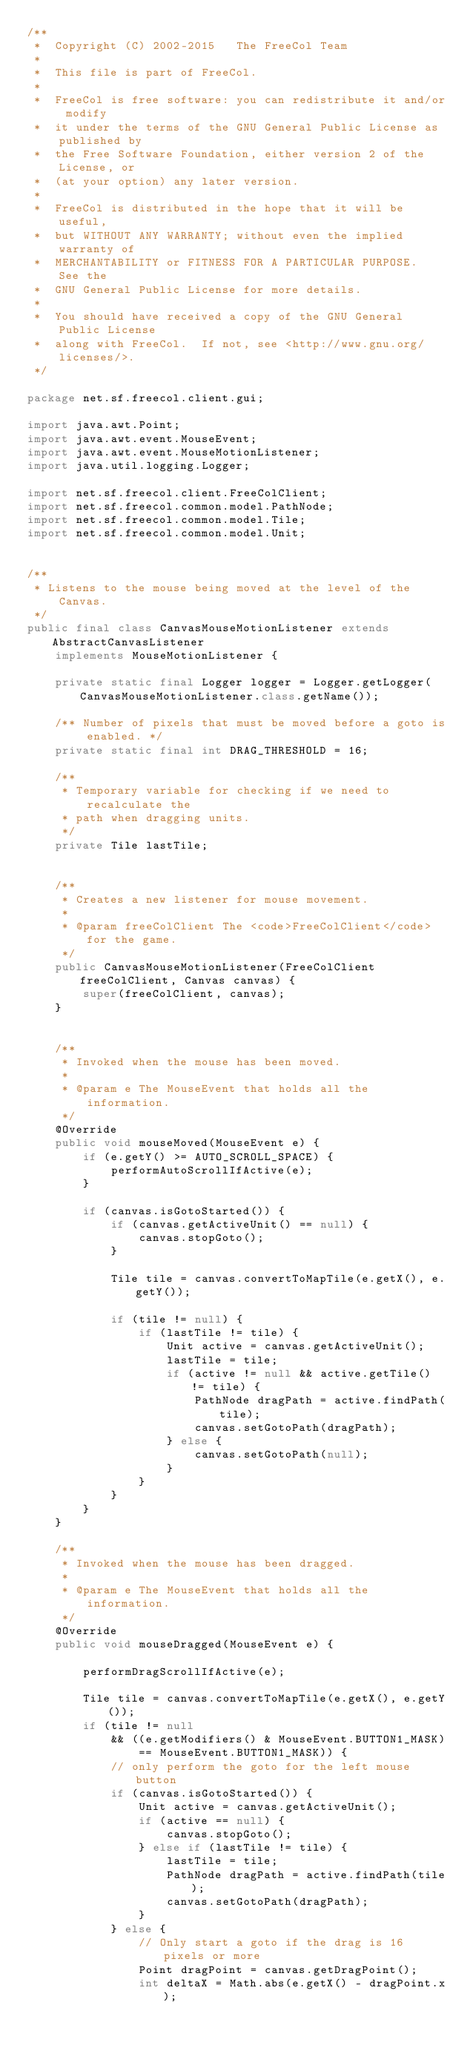<code> <loc_0><loc_0><loc_500><loc_500><_Java_>/**
 *  Copyright (C) 2002-2015   The FreeCol Team
 *
 *  This file is part of FreeCol.
 *
 *  FreeCol is free software: you can redistribute it and/or modify
 *  it under the terms of the GNU General Public License as published by
 *  the Free Software Foundation, either version 2 of the License, or
 *  (at your option) any later version.
 *
 *  FreeCol is distributed in the hope that it will be useful,
 *  but WITHOUT ANY WARRANTY; without even the implied warranty of
 *  MERCHANTABILITY or FITNESS FOR A PARTICULAR PURPOSE.  See the
 *  GNU General Public License for more details.
 *
 *  You should have received a copy of the GNU General Public License
 *  along with FreeCol.  If not, see <http://www.gnu.org/licenses/>.
 */

package net.sf.freecol.client.gui;

import java.awt.Point;
import java.awt.event.MouseEvent;
import java.awt.event.MouseMotionListener;
import java.util.logging.Logger;

import net.sf.freecol.client.FreeColClient;
import net.sf.freecol.common.model.PathNode;
import net.sf.freecol.common.model.Tile;
import net.sf.freecol.common.model.Unit;


/**
 * Listens to the mouse being moved at the level of the Canvas.
 */
public final class CanvasMouseMotionListener extends AbstractCanvasListener
    implements MouseMotionListener {

    private static final Logger logger = Logger.getLogger(CanvasMouseMotionListener.class.getName());

    /** Number of pixels that must be moved before a goto is enabled. */
    private static final int DRAG_THRESHOLD = 16;

    /**
     * Temporary variable for checking if we need to recalculate the
     * path when dragging units.
     */
    private Tile lastTile;
    

    /**
     * Creates a new listener for mouse movement.
     *
     * @param freeColClient The <code>FreeColClient</code> for the game.
     */
    public CanvasMouseMotionListener(FreeColClient freeColClient, Canvas canvas) {
        super(freeColClient, canvas);
    }


    /**
     * Invoked when the mouse has been moved.
     *
     * @param e The MouseEvent that holds all the information.
     */
    @Override
    public void mouseMoved(MouseEvent e) {
        if (e.getY() >= AUTO_SCROLL_SPACE) {
            performAutoScrollIfActive(e);
        }

        if (canvas.isGotoStarted()) {
            if (canvas.getActiveUnit() == null) {
                canvas.stopGoto();
            }

            Tile tile = canvas.convertToMapTile(e.getX(), e.getY());

            if (tile != null) {
                if (lastTile != tile) {
                    Unit active = canvas.getActiveUnit();
                    lastTile = tile;
                    if (active != null && active.getTile() != tile) {
                        PathNode dragPath = active.findPath(tile);
                        canvas.setGotoPath(dragPath);
                    } else {
                        canvas.setGotoPath(null);
                    }
                }
            }
        }
    }

    /**
     * Invoked when the mouse has been dragged.
     *
     * @param e The MouseEvent that holds all the information.
     */
    @Override
    public void mouseDragged(MouseEvent e) {

        performDragScrollIfActive(e);

        Tile tile = canvas.convertToMapTile(e.getX(), e.getY());
        if (tile != null
            && ((e.getModifiers() & MouseEvent.BUTTON1_MASK)
                == MouseEvent.BUTTON1_MASK)) {
            // only perform the goto for the left mouse button
            if (canvas.isGotoStarted()) {
                Unit active = canvas.getActiveUnit();
                if (active == null) {
                    canvas.stopGoto();
                } else if (lastTile != tile) {
                    lastTile = tile;
                    PathNode dragPath = active.findPath(tile);
                    canvas.setGotoPath(dragPath);
                }
            } else {
                // Only start a goto if the drag is 16 pixels or more
                Point dragPoint = canvas.getDragPoint();
                int deltaX = Math.abs(e.getX() - dragPoint.x);</code> 